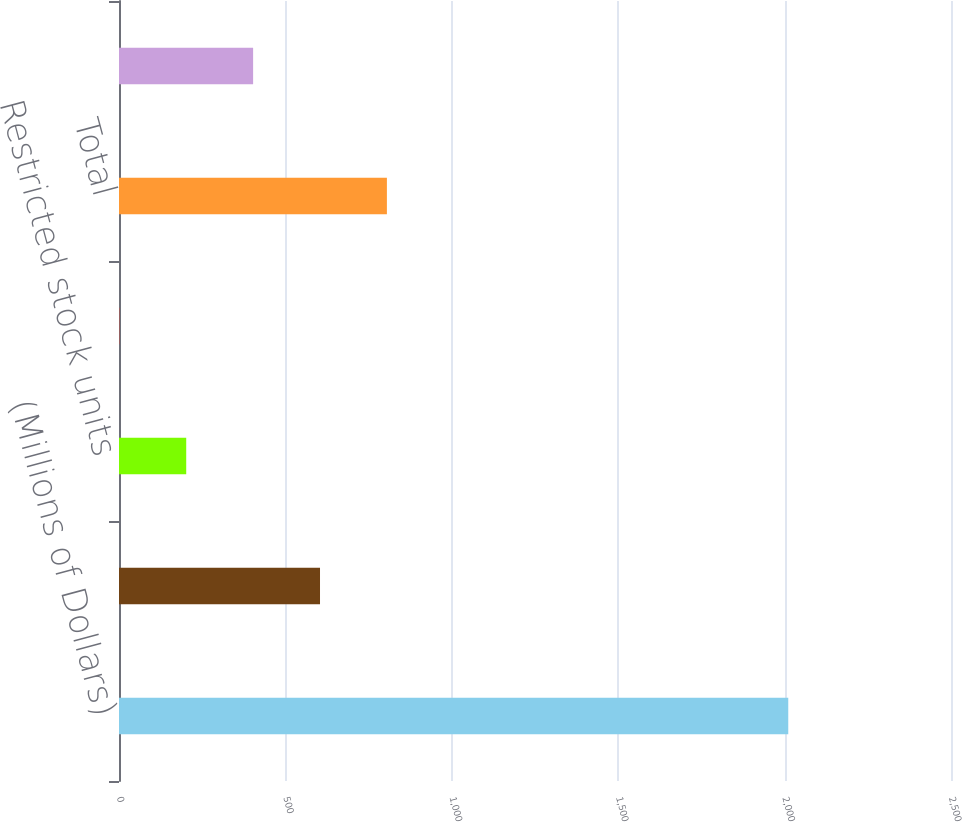Convert chart to OTSL. <chart><loc_0><loc_0><loc_500><loc_500><bar_chart><fcel>(Millions of Dollars)<fcel>Performance-based restricted<fcel>Restricted stock units<fcel>Non-officer director deferred<fcel>Total<fcel>Income Tax Benefit<nl><fcel>2011<fcel>604<fcel>202<fcel>1<fcel>805<fcel>403<nl></chart> 